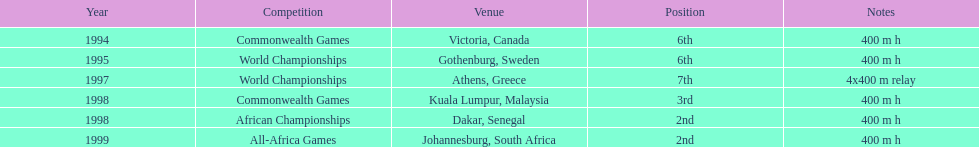Besides 1999, in which year did ken harnden secure the second position? 1998. 